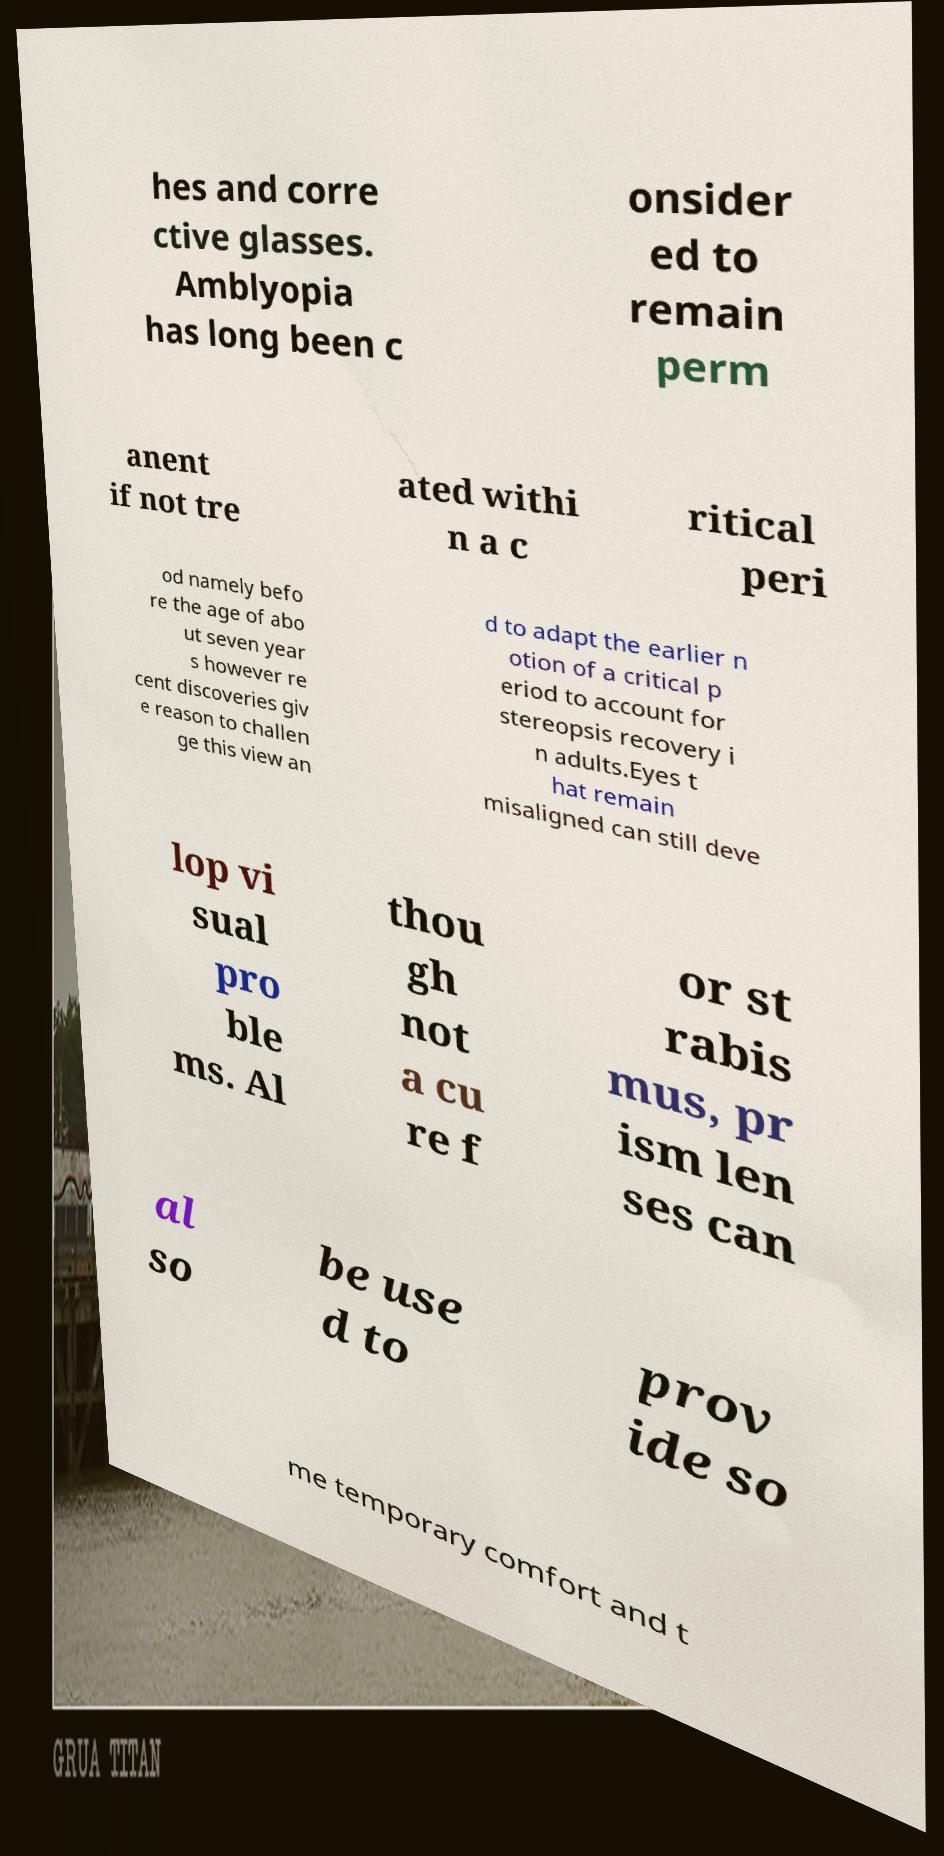There's text embedded in this image that I need extracted. Can you transcribe it verbatim? hes and corre ctive glasses. Amblyopia has long been c onsider ed to remain perm anent if not tre ated withi n a c ritical peri od namely befo re the age of abo ut seven year s however re cent discoveries giv e reason to challen ge this view an d to adapt the earlier n otion of a critical p eriod to account for stereopsis recovery i n adults.Eyes t hat remain misaligned can still deve lop vi sual pro ble ms. Al thou gh not a cu re f or st rabis mus, pr ism len ses can al so be use d to prov ide so me temporary comfort and t 